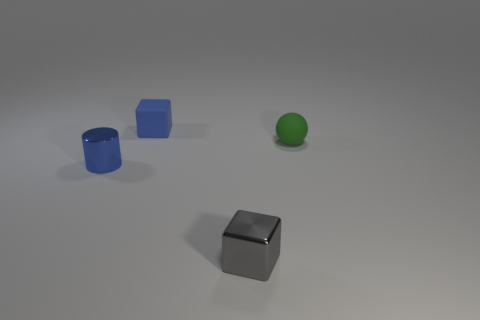Add 2 tiny blue objects. How many objects exist? 6 Subtract all cylinders. How many objects are left? 3 Subtract all green metallic blocks. Subtract all green matte spheres. How many objects are left? 3 Add 2 tiny blue cylinders. How many tiny blue cylinders are left? 3 Add 3 tiny cyan shiny cubes. How many tiny cyan shiny cubes exist? 3 Subtract 1 gray cubes. How many objects are left? 3 